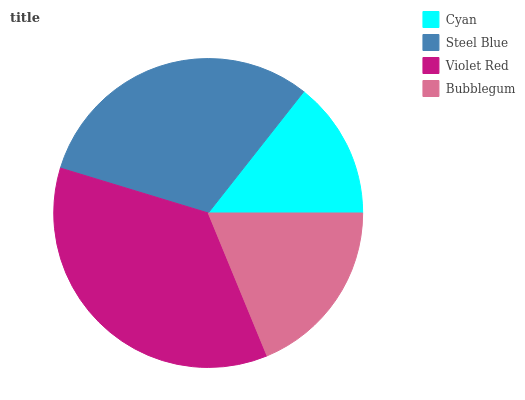Is Cyan the minimum?
Answer yes or no. Yes. Is Violet Red the maximum?
Answer yes or no. Yes. Is Steel Blue the minimum?
Answer yes or no. No. Is Steel Blue the maximum?
Answer yes or no. No. Is Steel Blue greater than Cyan?
Answer yes or no. Yes. Is Cyan less than Steel Blue?
Answer yes or no. Yes. Is Cyan greater than Steel Blue?
Answer yes or no. No. Is Steel Blue less than Cyan?
Answer yes or no. No. Is Steel Blue the high median?
Answer yes or no. Yes. Is Bubblegum the low median?
Answer yes or no. Yes. Is Bubblegum the high median?
Answer yes or no. No. Is Violet Red the low median?
Answer yes or no. No. 